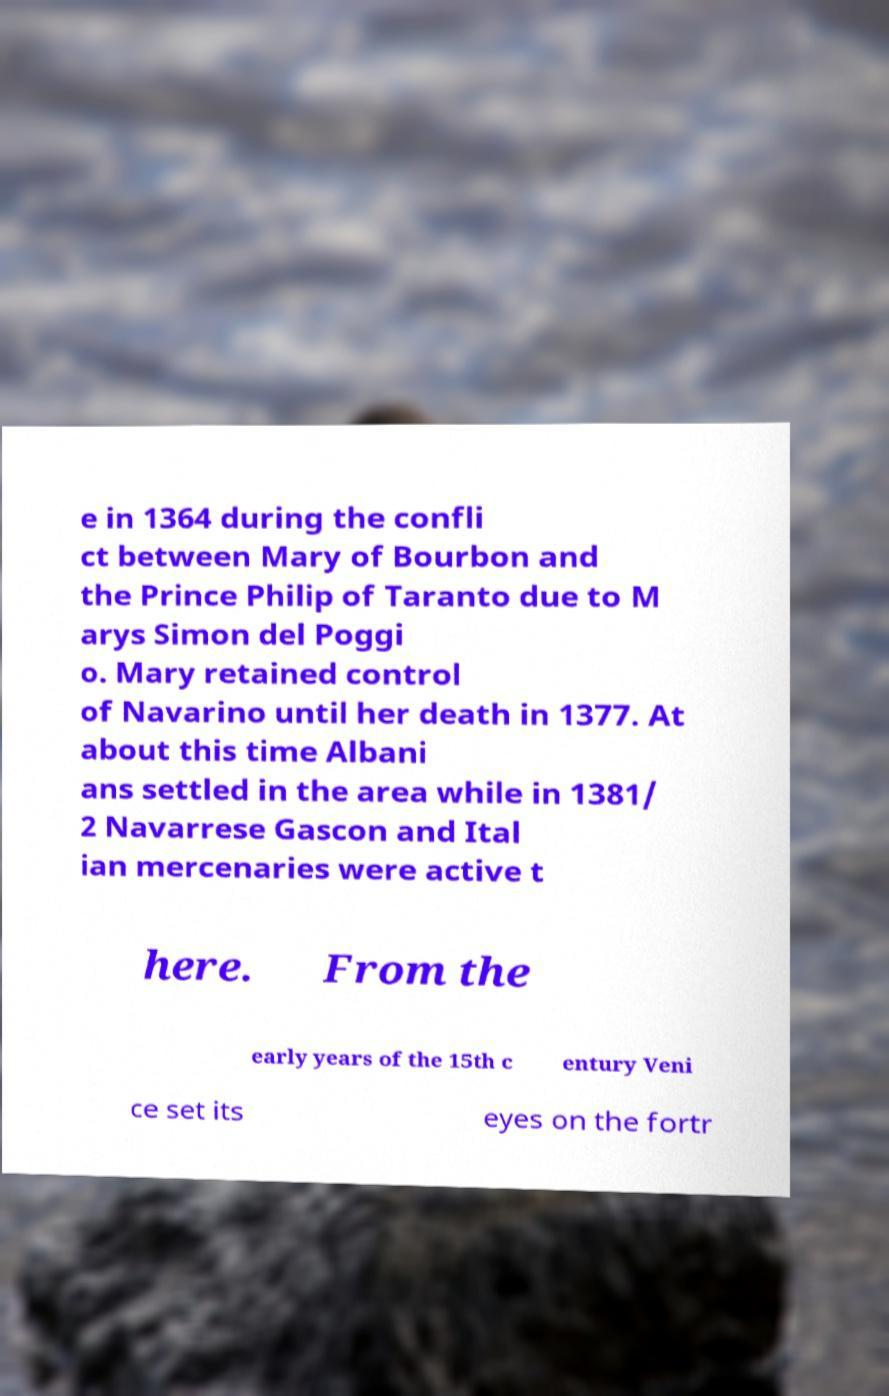Can you accurately transcribe the text from the provided image for me? e in 1364 during the confli ct between Mary of Bourbon and the Prince Philip of Taranto due to M arys Simon del Poggi o. Mary retained control of Navarino until her death in 1377. At about this time Albani ans settled in the area while in 1381/ 2 Navarrese Gascon and Ital ian mercenaries were active t here. From the early years of the 15th c entury Veni ce set its eyes on the fortr 